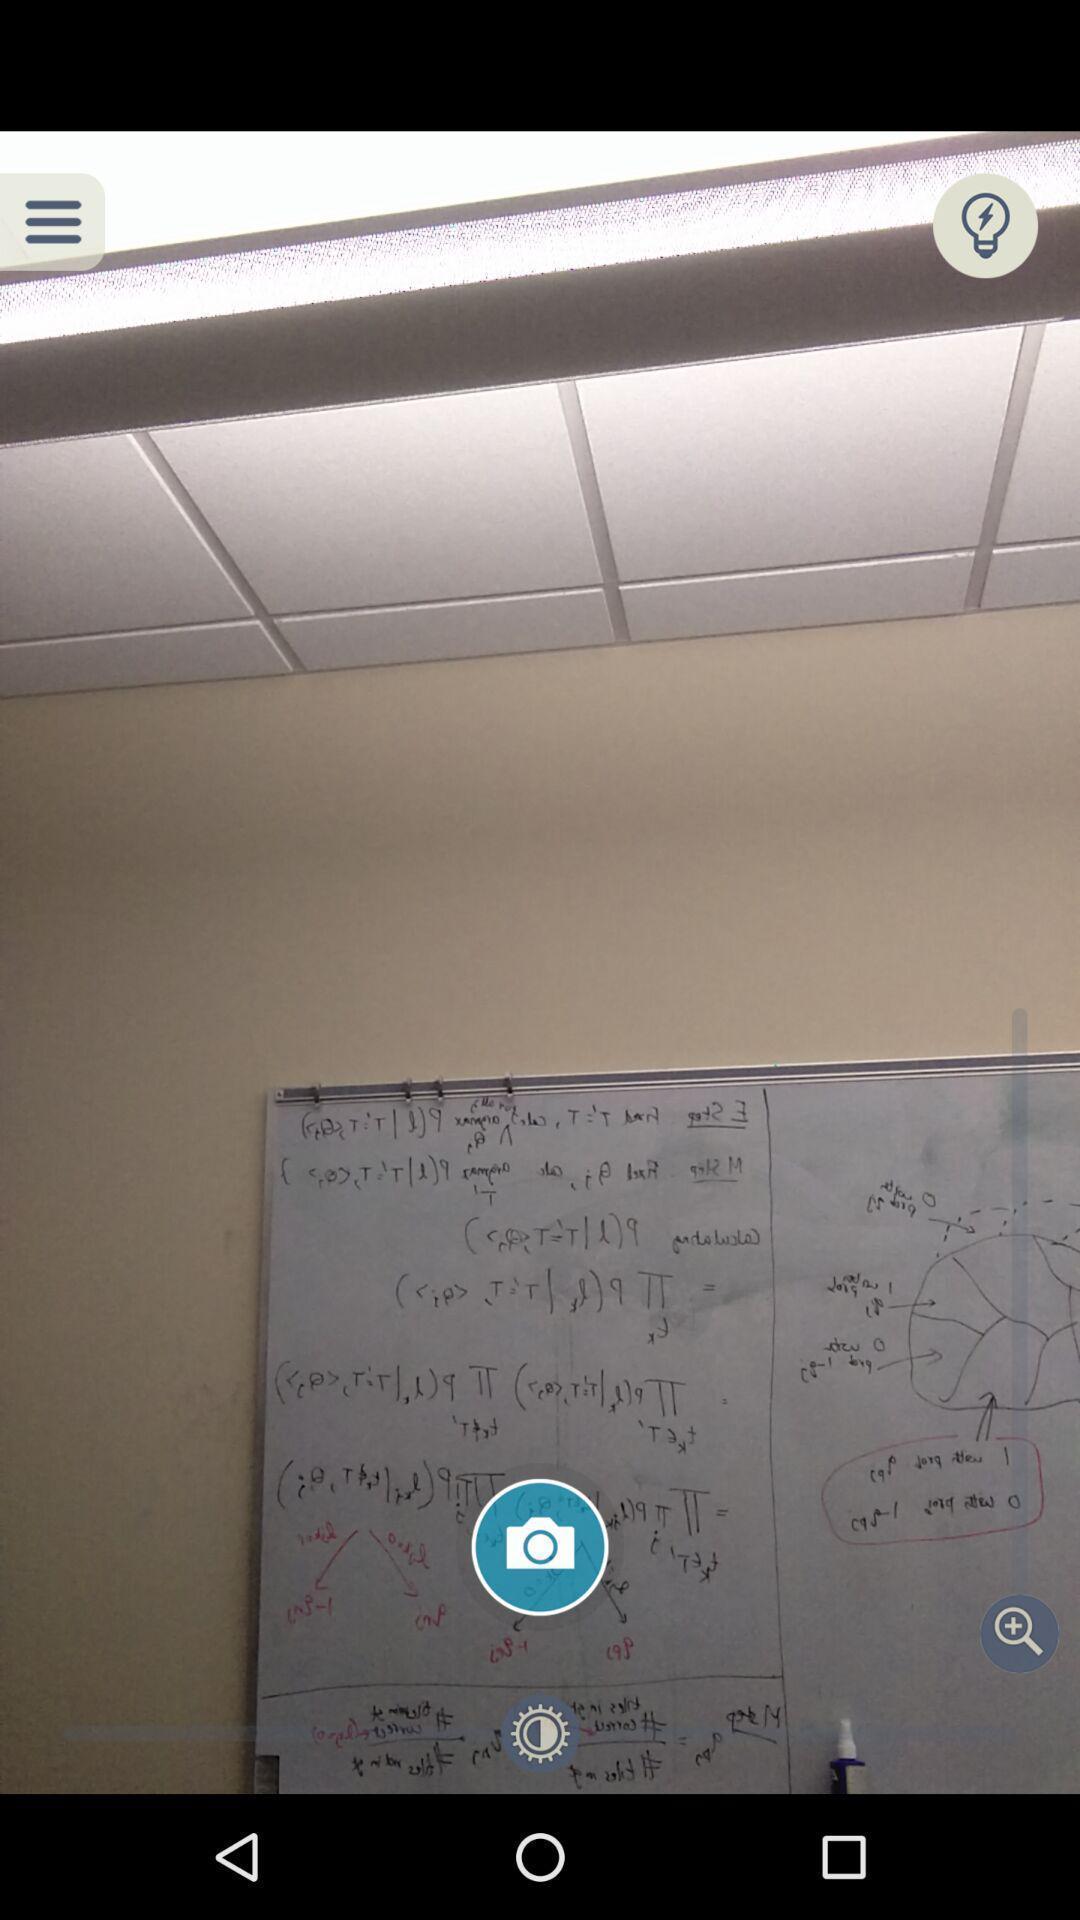Tell me what you see in this picture. Screen shows an image with multiple options. 